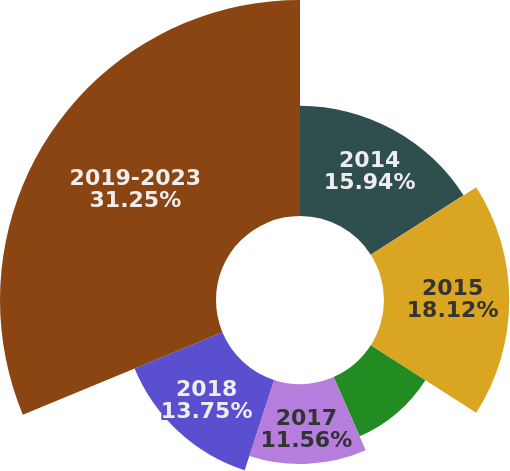Convert chart to OTSL. <chart><loc_0><loc_0><loc_500><loc_500><pie_chart><fcel>2014<fcel>2015<fcel>2016<fcel>2017<fcel>2018<fcel>2019-2023<nl><fcel>15.94%<fcel>18.12%<fcel>9.38%<fcel>11.56%<fcel>13.75%<fcel>31.25%<nl></chart> 